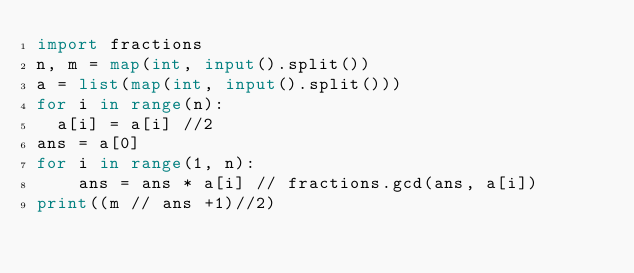<code> <loc_0><loc_0><loc_500><loc_500><_Python_>import fractions
n, m = map(int, input().split())
a = list(map(int, input().split()))
for i in range(n):
  a[i] = a[i] //2
ans = a[0]
for i in range(1, n):
    ans = ans * a[i] // fractions.gcd(ans, a[i])
print((m // ans +1)//2)
</code> 